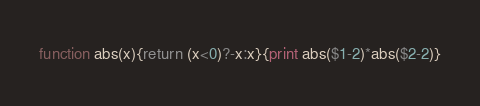<code> <loc_0><loc_0><loc_500><loc_500><_Awk_>function abs(x){return (x<0)?-x:x}{print abs($1-2)*abs($2-2)}</code> 